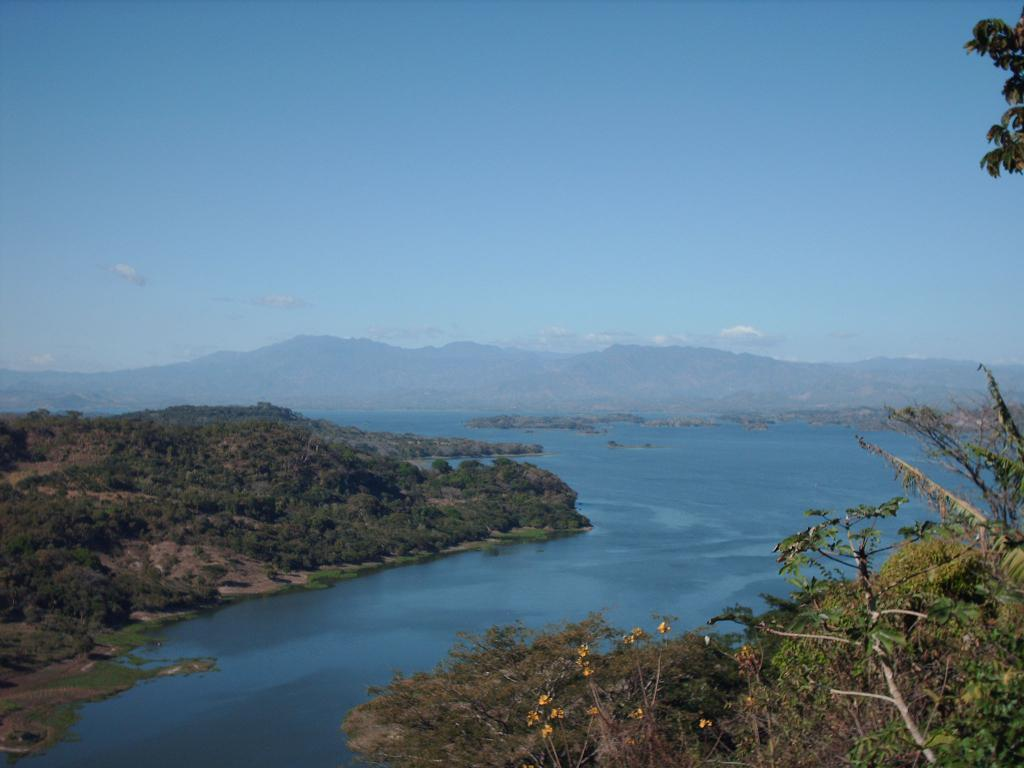What type of natural environment is depicted in the image? The image features trees, water, and hills, which are elements of a natural environment. Can you describe the water in the image? There is water visible in the image, but its specific characteristics are not mentioned in the facts. What is visible in the background of the image? The sky is visible in the background of the image, and there are clouds in the sky. Where is the notebook placed in the image? There is no notebook present in the image. What type of mass can be seen in the image? The facts provided do not mention any mass in the image. 